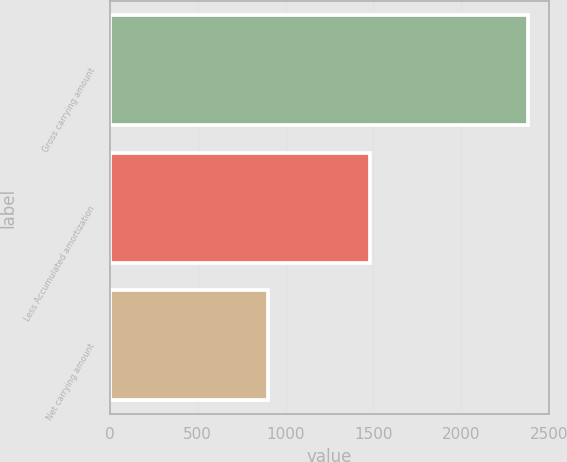Convert chart. <chart><loc_0><loc_0><loc_500><loc_500><bar_chart><fcel>Gross carrying amount<fcel>Less Accumulated amortization<fcel>Net carrying amount<nl><fcel>2381<fcel>1479<fcel>902<nl></chart> 